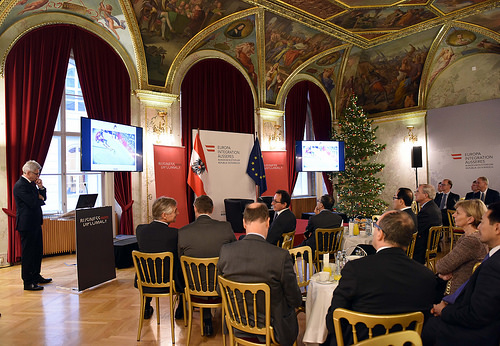<image>
Is the guy in front of the guy? Yes. The guy is positioned in front of the guy, appearing closer to the camera viewpoint. 